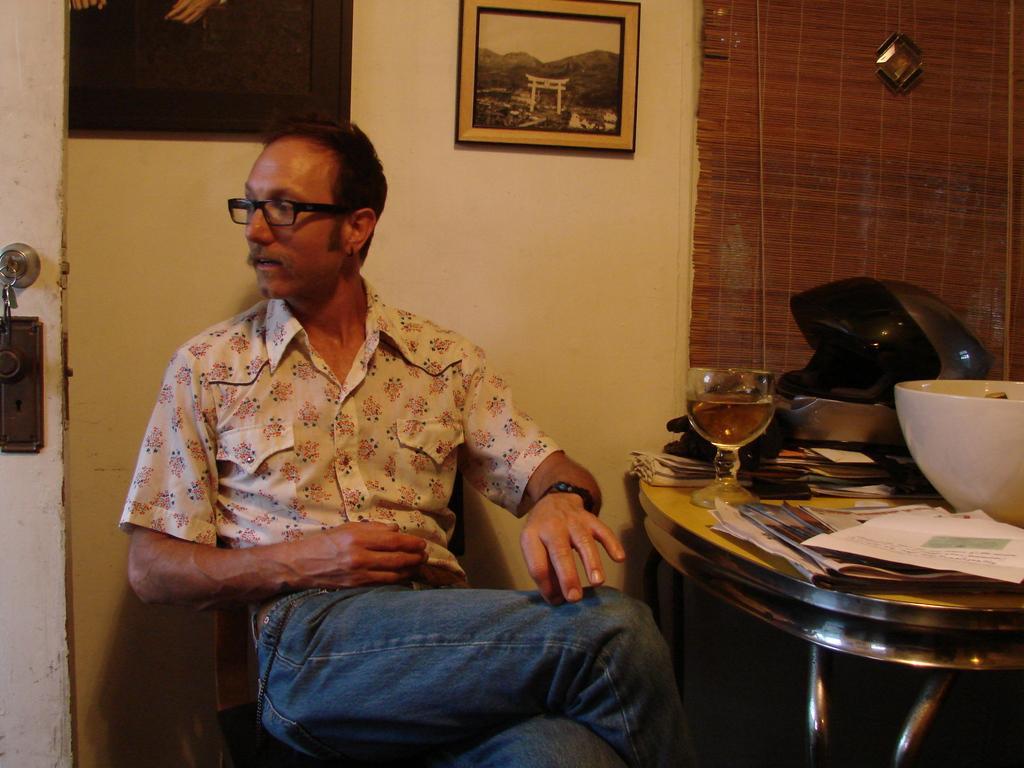How would you summarize this image in a sentence or two? This image consists of a man sitting on a chair. He is wearing a jeans pant. On the right, we can see a table on which there is a bowl in white color. And there are papers, helmet and a glass of wine. In the background, we can see a wall on which there are two frames. On the left, there is a door. 